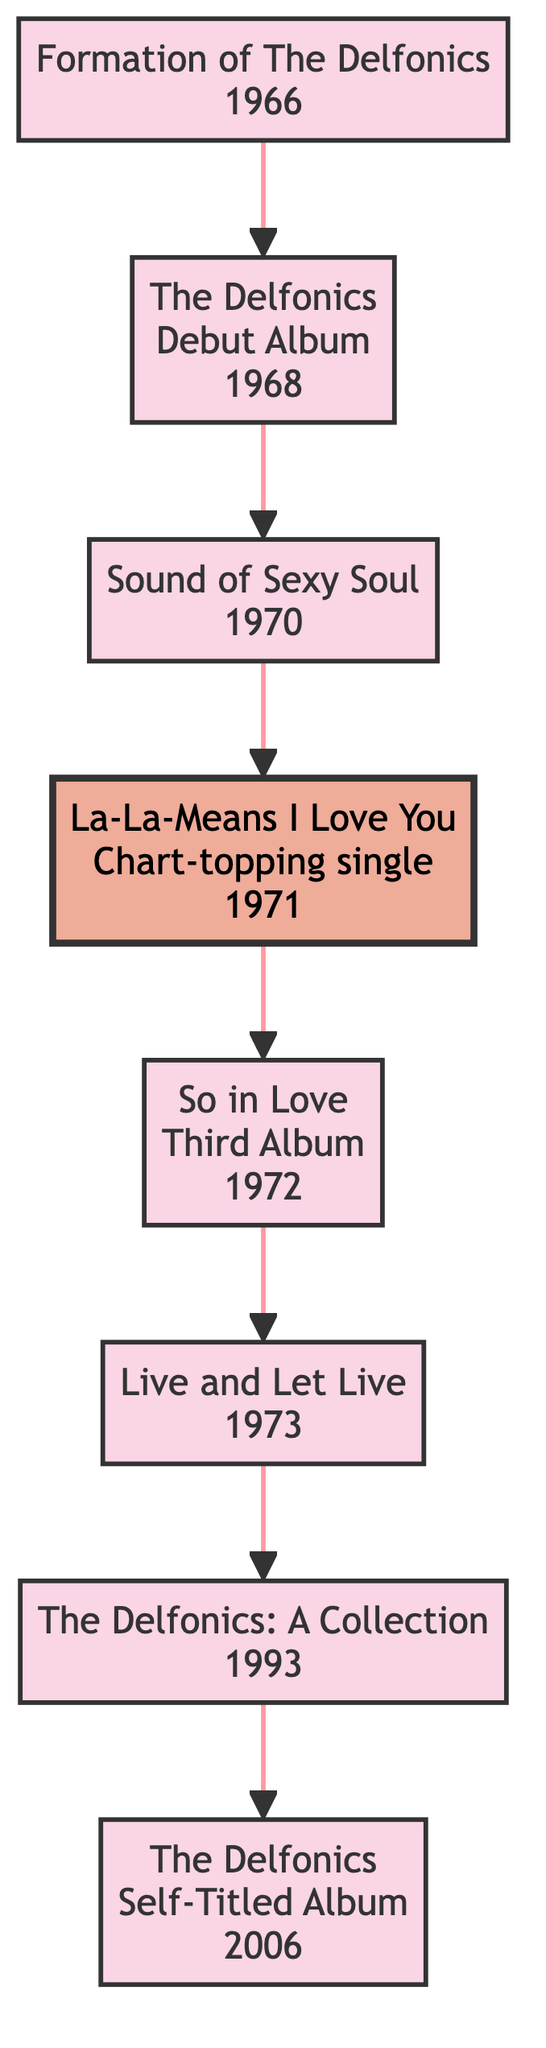What year was The Delfonics formed? The diagram indicates that The Delfonics were formed in the year 1966, which is represented as the first event in the timeline.
Answer: 1966 What is the title of The Delfonics' debut album? The flowchart shows that the debut album of The Delfonics is titled "The Delfonics," released in 1968, directly following the formation event.
Answer: The Delfonics Which event follows the release of "So in Love"? According to the diagram, the release of "So in Love" in 1972 is followed by the event "Live and Let Live," which occurred in 1973.
Answer: Live and Let Live How many albums are listed in the timeline? The diagram includes a total of five albums: "The Delfonics," "Sound of Sexy Soul," "So in Love," "Live and Let Live," and "The Delfonics" (Self-Titled Album). Each of these albums is represented as an event in the flowchart.
Answer: 5 What milestone event is highlighted in 1971? The chart specifies that the milestone event in 1971 is the release of the chart-topping single, "La-La-Means I Love You," which is marked distinctly as a milestone in the diagram.
Answer: La-La-Means I Love You Which album was released the longest time after the formation of The Delfonics? By analyzing the timeline, the album "The Delfonics" (Self-Titled Album) was released in 2006, which is 40 years after the group’s formation in 1966, making it the longest time gap represented.
Answer: The Delfonics Identify the first album released by The Delfonics. The flowchart shows that the first album released by The Delfonics after their formation is "The Delfonics" in 1968, positioned immediately after the formation year.
Answer: The Delfonics What is the connection between the chart-topping single and the third album? The timeline conveys that the chart-topping single "La-La-Means I Love You" (1971) occurs between the release of the album "Sound of Sexy Soul" (1970) and the third album "So in Love" (1972), linking them within the timeline.
Answer: Sequential order In which year was "The Delfonics: A Collection" released? The diagram indicates that "The Delfonics: A Collection" was released in 1993, which is represented as the sixth node in the flowchart timeline.
Answer: 1993 